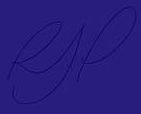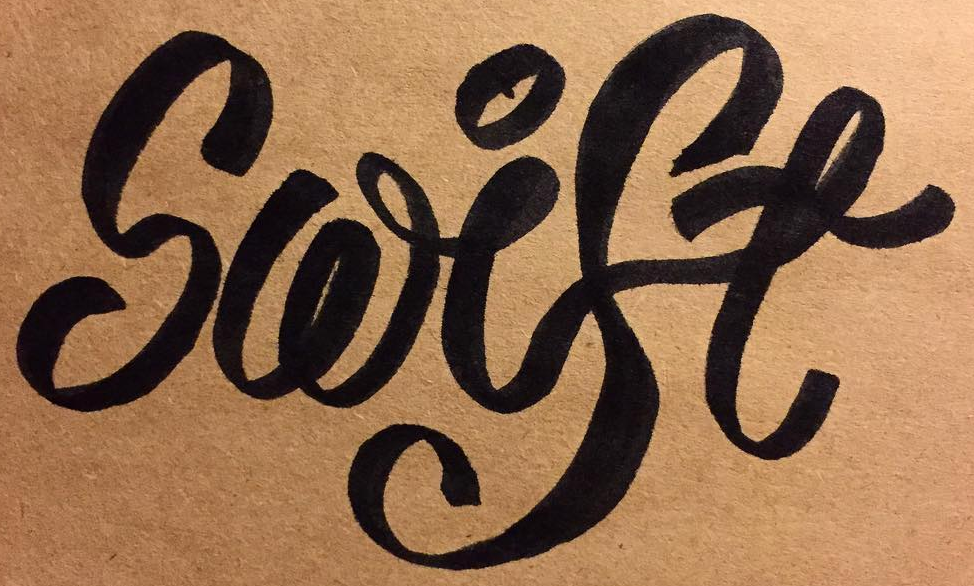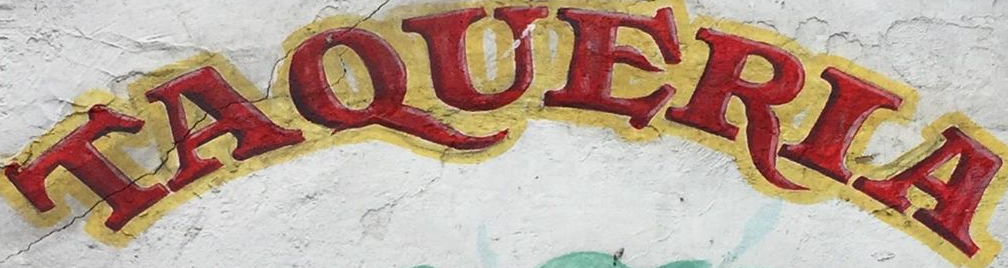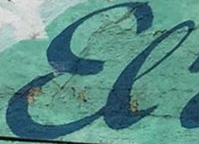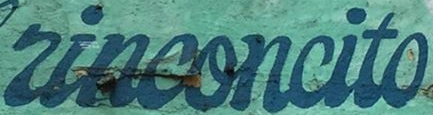Identify the words shown in these images in order, separated by a semicolon. RJP; Swise; TAQUERIA; El; rinconcito 